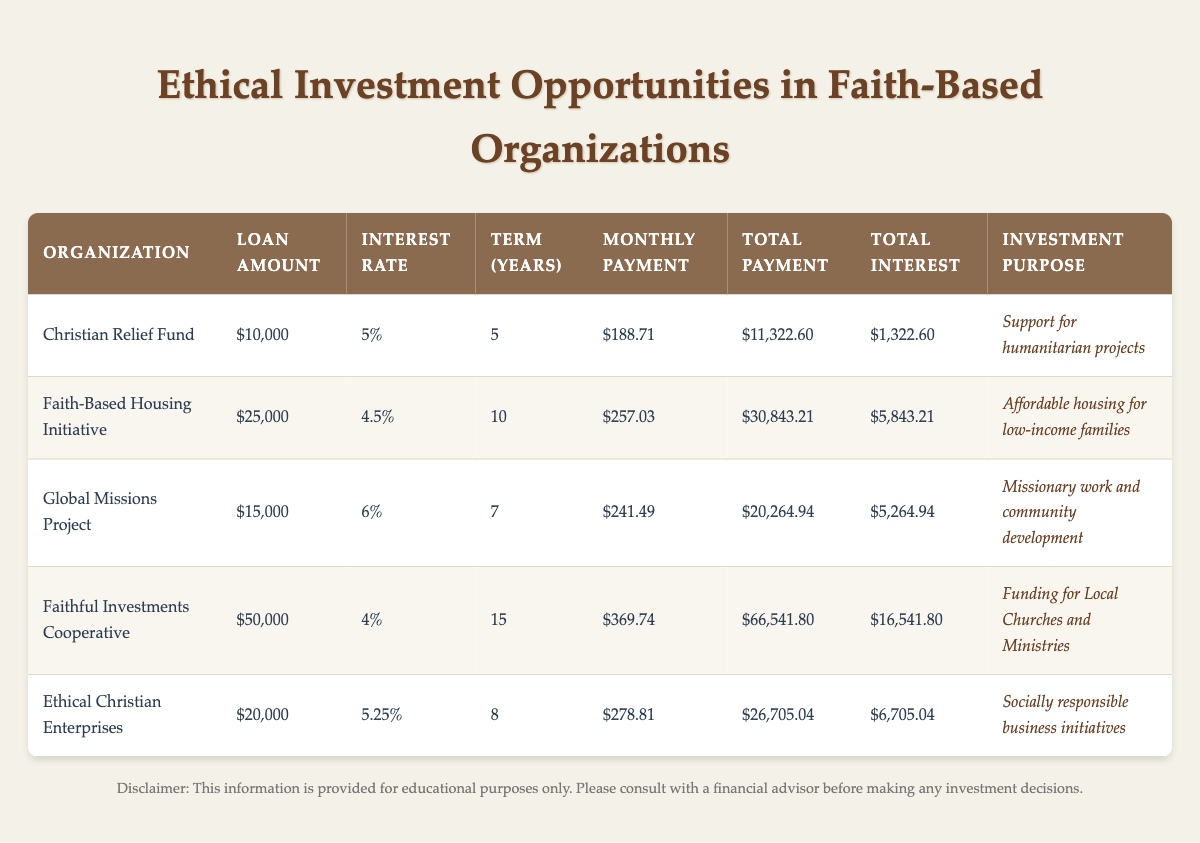What is the total payment for the Faith-Based Housing Initiative? According to the table, the total payment for the Faith-Based Housing Initiative is listed as $30,843.21.
Answer: $30,843.21 What is the monthly payment for the Global Missions Project? The monthly payment for the Global Missions Project is stated as $241.49 in the table.
Answer: $241.49 Which organization has the highest total interest paid? By analyzing the total interest columns for each organization, Faithful Investments Cooperative has the highest total interest paid at $16,541.80.
Answer: Faithful Investments Cooperative What is the average loan amount across all investment opportunities? To find the average loan amount, first, sum the loan amounts: $10,000 + $25,000 + $15,000 + $50,000 + $20,000 = $120,000. Then divide by the number of organizations, which is 5: $120,000 / 5 = $24,000.
Answer: $24,000 Is the loan amount for Ethical Christian Enterprises greater than $15,000? The loan amount for Ethical Christian Enterprises is $20,000, which is indeed greater than $15,000.
Answer: Yes Which investment purpose has the lowest loan amount? By comparing the loan amounts, the Christian Relief Fund, with a loan amount of $10,000, has the lowest loan amount among the listed organizations.
Answer: Christian Relief Fund What is the difference in the total payment between the Faithful Investments Cooperative and the Christian Relief Fund? The total payment for Faithful Investments Cooperative is $66,541.80 and for Christian Relief Fund is $11,322.60. To find the difference, subtract $11,322.60 from $66,541.80, which equals $55,219.20.
Answer: $55,219.20 Is the interest rate for the Faith-Based Housing Initiative lower than the average interest rate of all organizations? First, calculate the average interest rate: (5 + 4.5 + 6 + 4 + 5.25) / 5 = 5.15. The interest rate for Faith-Based Housing Initiative is 4.5, which is lower than 5.15.
Answer: Yes How many organizations have a loan term of more than 10 years? By reviewing the loan term column, only the Faithful Investments Cooperative with 15 years has a loan term greater than 10 years. Hence, there is 1 organization.
Answer: 1 